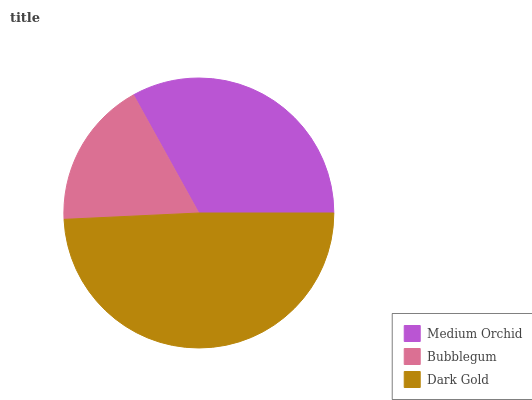Is Bubblegum the minimum?
Answer yes or no. Yes. Is Dark Gold the maximum?
Answer yes or no. Yes. Is Dark Gold the minimum?
Answer yes or no. No. Is Bubblegum the maximum?
Answer yes or no. No. Is Dark Gold greater than Bubblegum?
Answer yes or no. Yes. Is Bubblegum less than Dark Gold?
Answer yes or no. Yes. Is Bubblegum greater than Dark Gold?
Answer yes or no. No. Is Dark Gold less than Bubblegum?
Answer yes or no. No. Is Medium Orchid the high median?
Answer yes or no. Yes. Is Medium Orchid the low median?
Answer yes or no. Yes. Is Bubblegum the high median?
Answer yes or no. No. Is Dark Gold the low median?
Answer yes or no. No. 